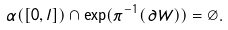Convert formula to latex. <formula><loc_0><loc_0><loc_500><loc_500>\alpha ( [ 0 , l ] ) \cap \exp ( \pi ^ { - 1 } ( \partial W ) ) = \emptyset .</formula> 